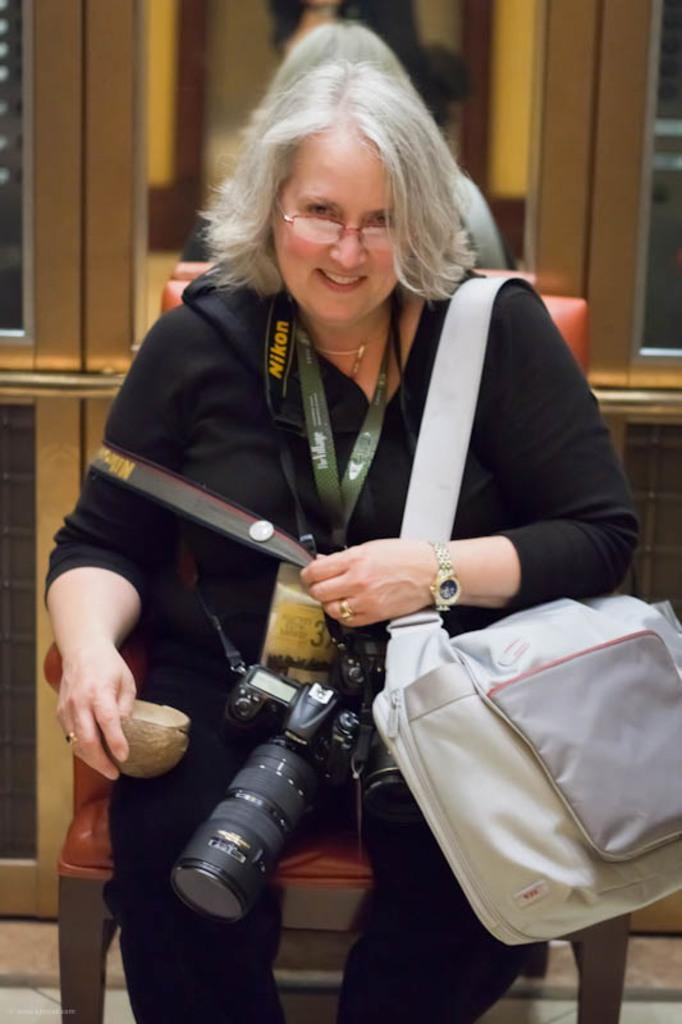Who is the main subject in the image? There is a woman in the image. What is the woman wearing? The woman is wearing a black dress. What is the woman holding in the image? The woman is holding a camera. What other object can be seen in the image? There is a bag in the image. What can be seen in the background of the image? There is a photo frame in the background of the image. What type of ray is swimming in the background of the image? There is no ray present in the image; it features a woman holding a camera, a bag, and a photo frame in the background. Is there a tub visible in the image? No, there is no tub present in the image. 